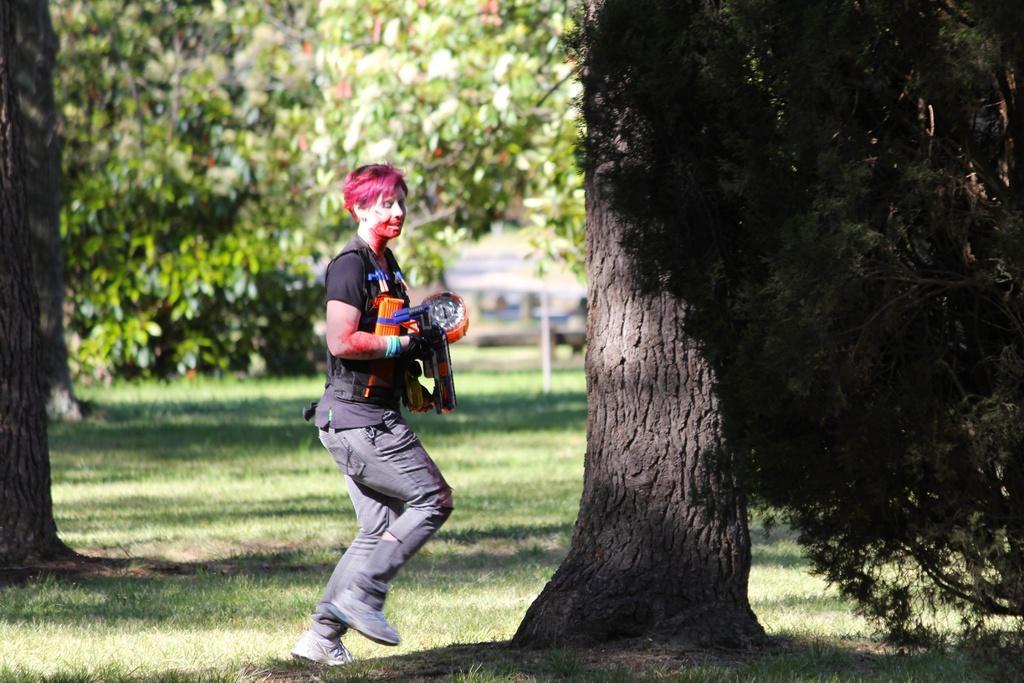Describe this image in one or two sentences. A person is jumping, this person wore black color t-shirt, trouser, shoes. There are trees in this image. 